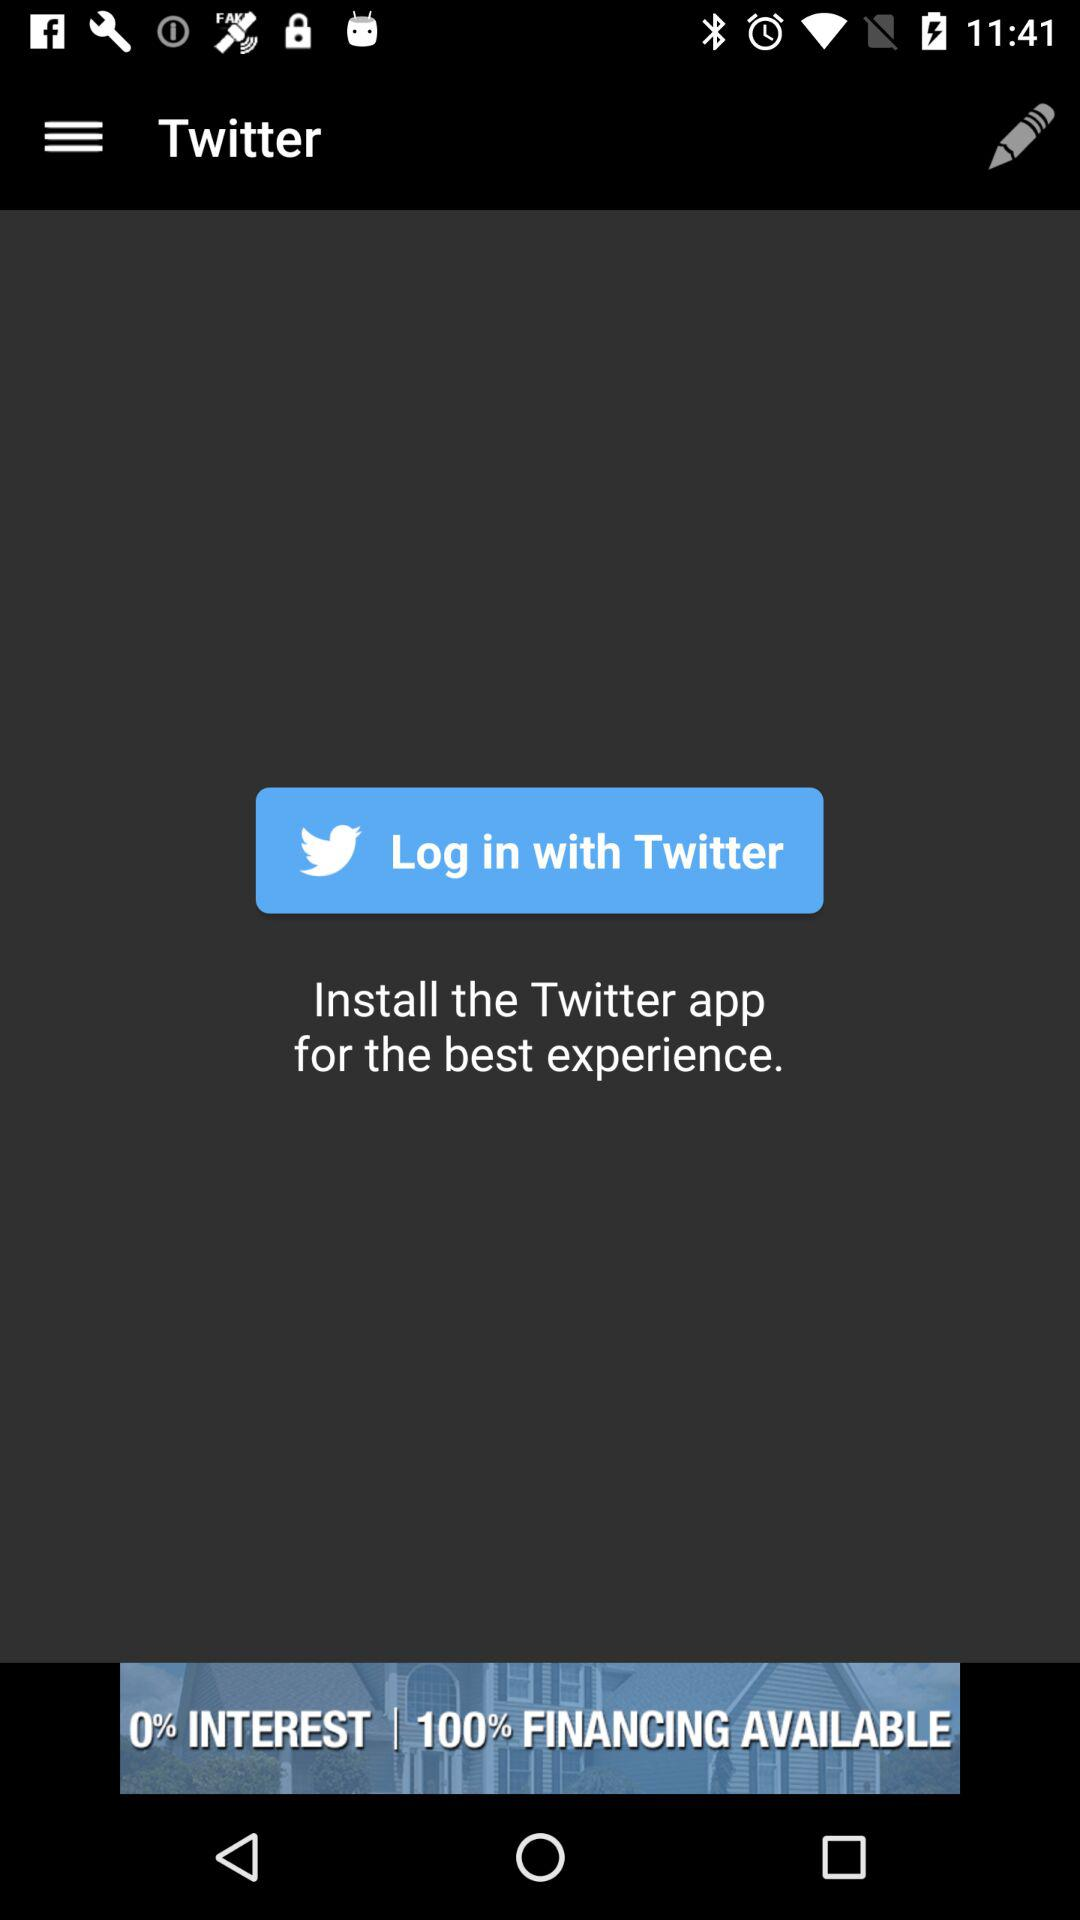What is the name of the application? The name of the application is "Twitter". 